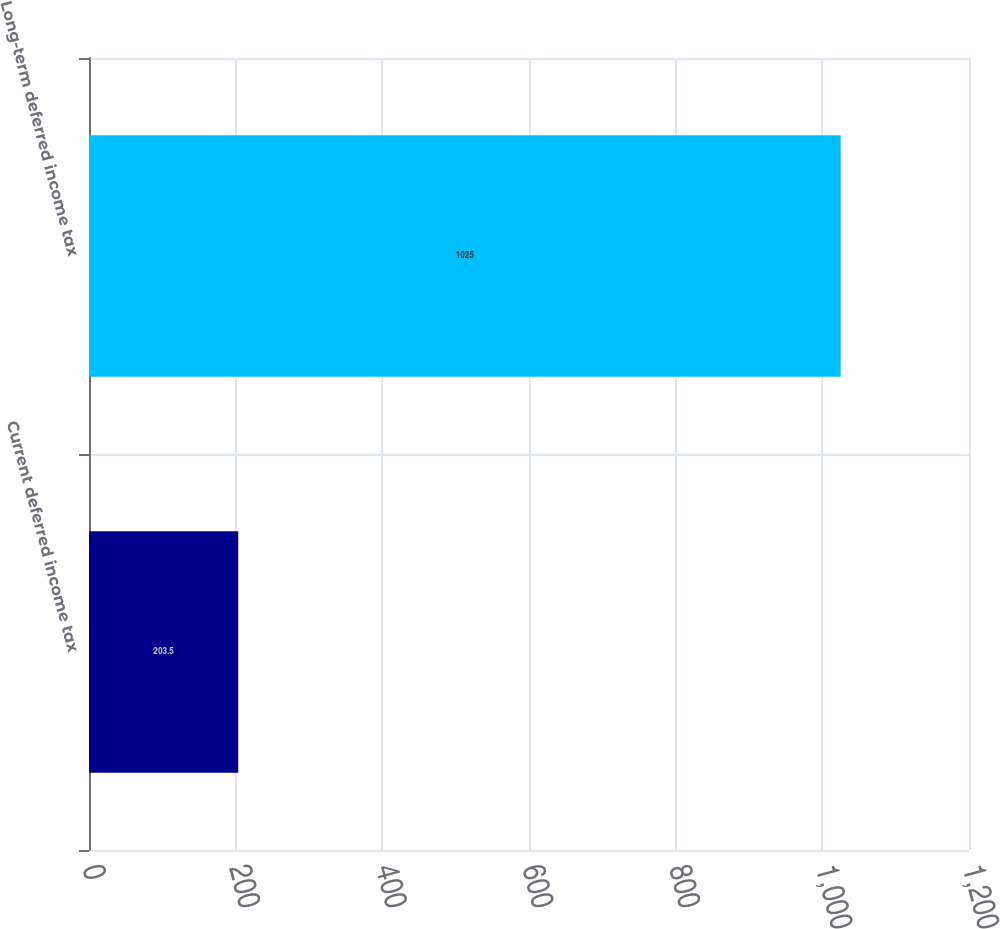Convert chart to OTSL. <chart><loc_0><loc_0><loc_500><loc_500><bar_chart><fcel>Current deferred income tax<fcel>Long-term deferred income tax<nl><fcel>203.5<fcel>1025<nl></chart> 